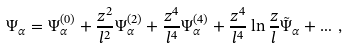Convert formula to latex. <formula><loc_0><loc_0><loc_500><loc_500>\Psi _ { \alpha } = \Psi _ { \alpha } ^ { ( 0 ) } + \frac { z ^ { 2 } } { l ^ { 2 } } \Psi _ { \alpha } ^ { ( 2 ) } + \frac { z ^ { 4 } } { l ^ { 4 } } \Psi _ { \alpha } ^ { ( 4 ) } + \frac { z ^ { 4 } } { l ^ { 4 } } \ln \frac { z } { l } \tilde { \Psi } _ { \alpha } + \dots \, ,</formula> 